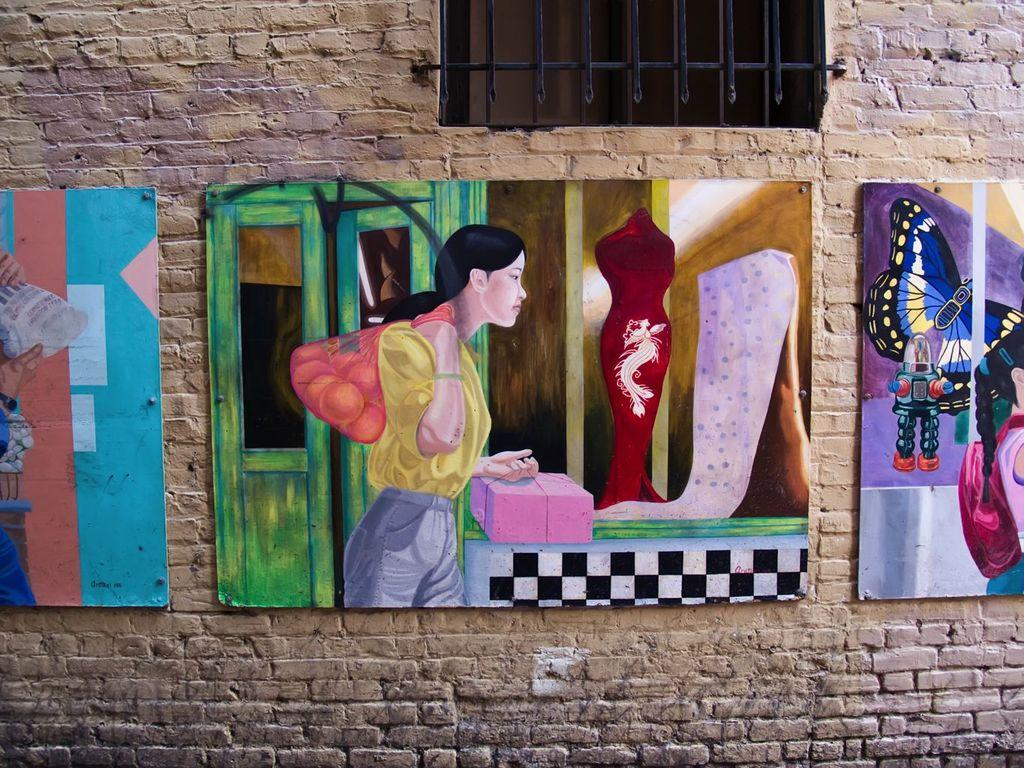What is the main subject in the center of the image? There are many photo frames in the center of the image. Where are the photo frames located? The photo frames are on a wall. What can be seen at the top of the image? There is a window at the top of the image. What type of knowledge does the manager share with the team in the image? There is no manager or team present in the image; it only features photo frames on a wall and a window. 